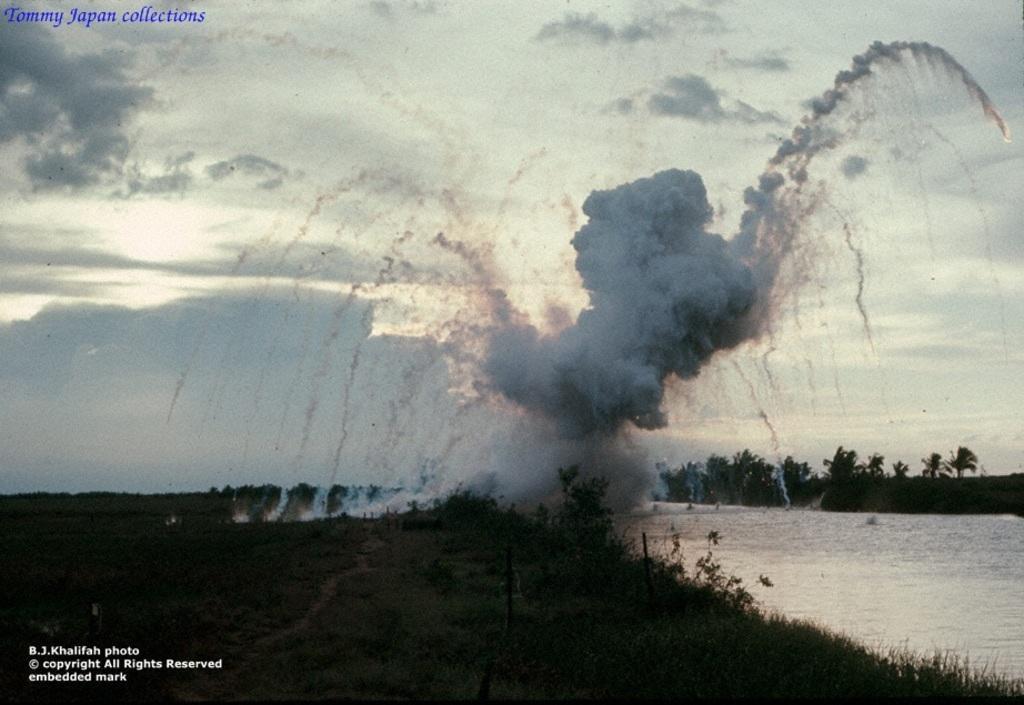Describe this image in one or two sentences. In this image there are plants and grass on the ground. To the right there is the water. In the background there are trees. In the center there is the smoke. At the top there is the sky. In the top left and the bottom left there is text on the image. The smoke seems to be an explosion. 